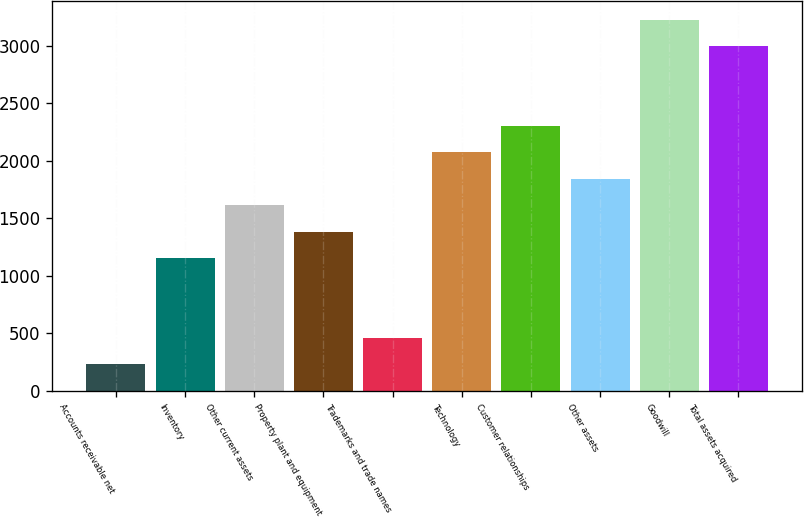<chart> <loc_0><loc_0><loc_500><loc_500><bar_chart><fcel>Accounts receivable net<fcel>Inventory<fcel>Other current assets<fcel>Property plant and equipment<fcel>Trademarks and trade names<fcel>Technology<fcel>Customer relationships<fcel>Other assets<fcel>Goodwill<fcel>Total assets acquired<nl><fcel>231<fcel>1152.2<fcel>1612.8<fcel>1382.5<fcel>461.3<fcel>2073.4<fcel>2303.7<fcel>1843.1<fcel>3224.9<fcel>2994.6<nl></chart> 